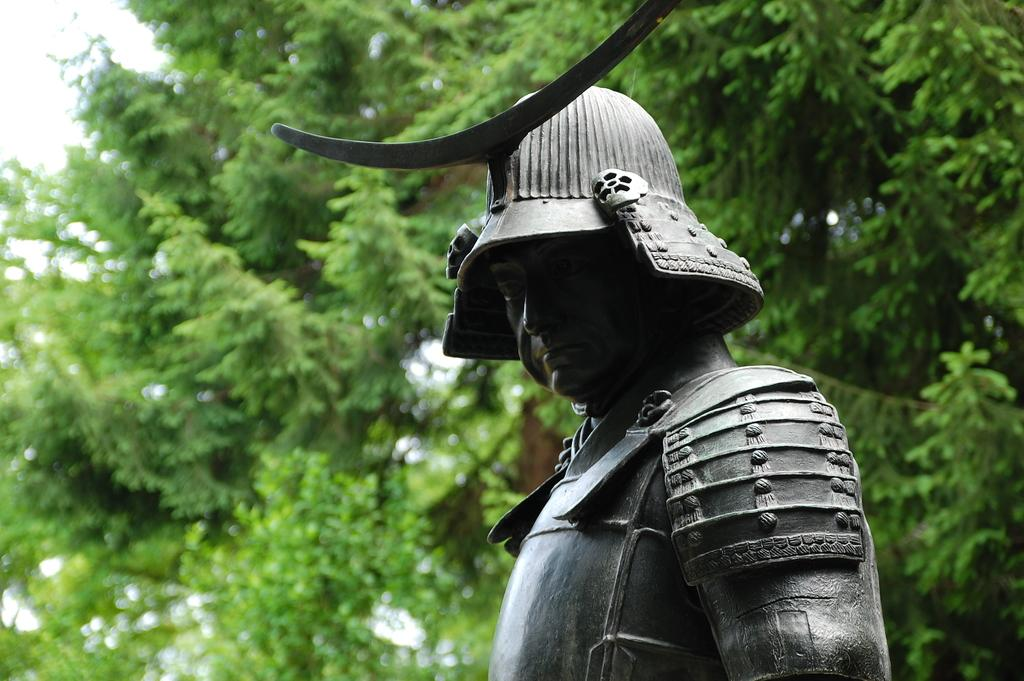Where was the image taken? The image was clicked outside. What is the main subject in the foreground of the image? There is a sculpture of a person in the foreground of the image. What can be seen in the background of the image? There are trees in the background of the image. Can you see a friend wearing a veil in the image? There is no friend or veil present in the image; it features a sculpture of a person and trees in the background. 